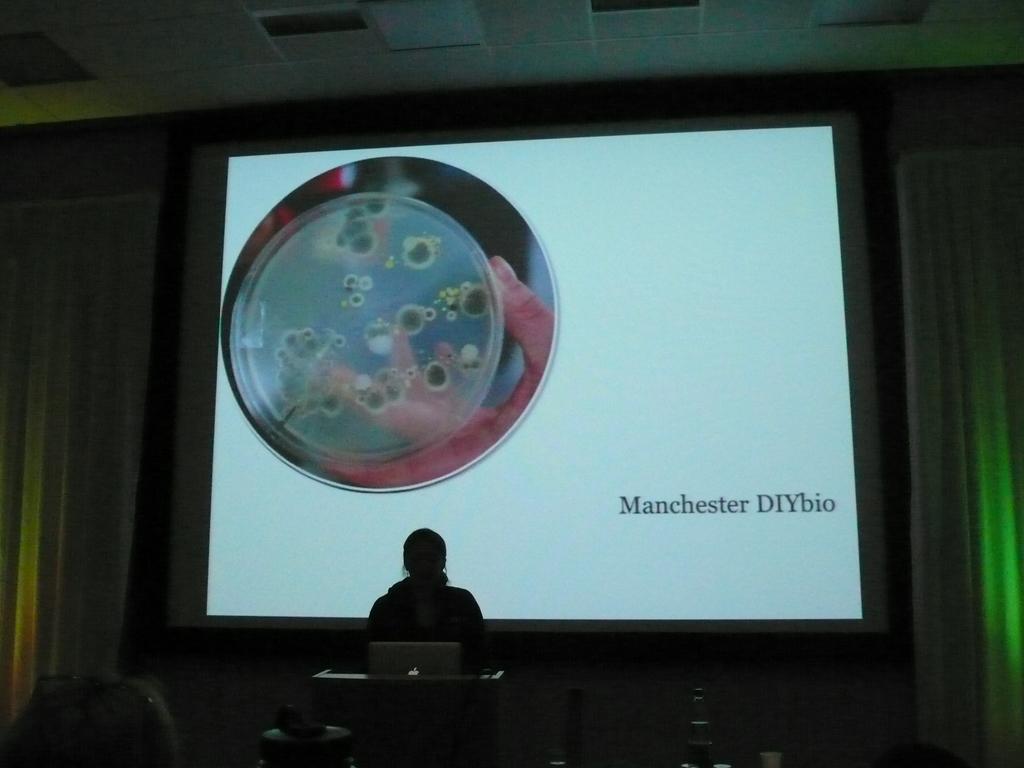From which topic could this presentation be from?
Offer a terse response. Manchester diybio. Who made this presentation?
Ensure brevity in your answer.  Manchester diybio. 